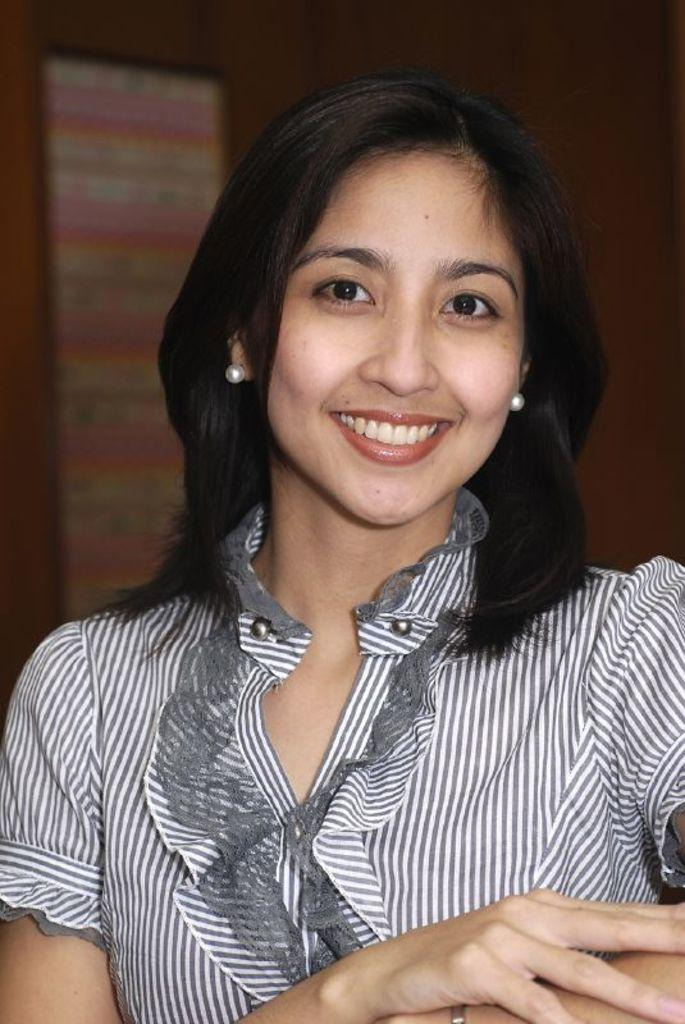Who is the main subject in the foreground of the image? There is a woman in the foreground of the image. What is the woman's facial expression in the image? The woman is smiling in the image. Can you describe the background of the image? The background of the image is blurry. What objects can be seen in the background of the image? There is a board and a wall visible in the background. What type of produce is the woman holding in the image? There is no produce visible in the image; the woman is not holding any fruits or vegetables. What book is the woman reading in the image? There is no book present in the image; the woman is not reading. 